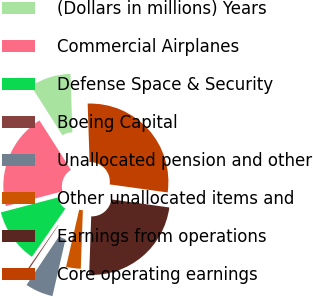Convert chart. <chart><loc_0><loc_0><loc_500><loc_500><pie_chart><fcel>(Dollars in millions) Years<fcel>Commercial Airplanes<fcel>Defense Space & Security<fcel>Boeing Capital<fcel>Unallocated pension and other<fcel>Other unallocated items and<fcel>Earnings from operations<fcel>Core operating earnings<nl><fcel>8.51%<fcel>20.05%<fcel>11.26%<fcel>0.29%<fcel>5.77%<fcel>3.03%<fcel>23.37%<fcel>27.71%<nl></chart> 